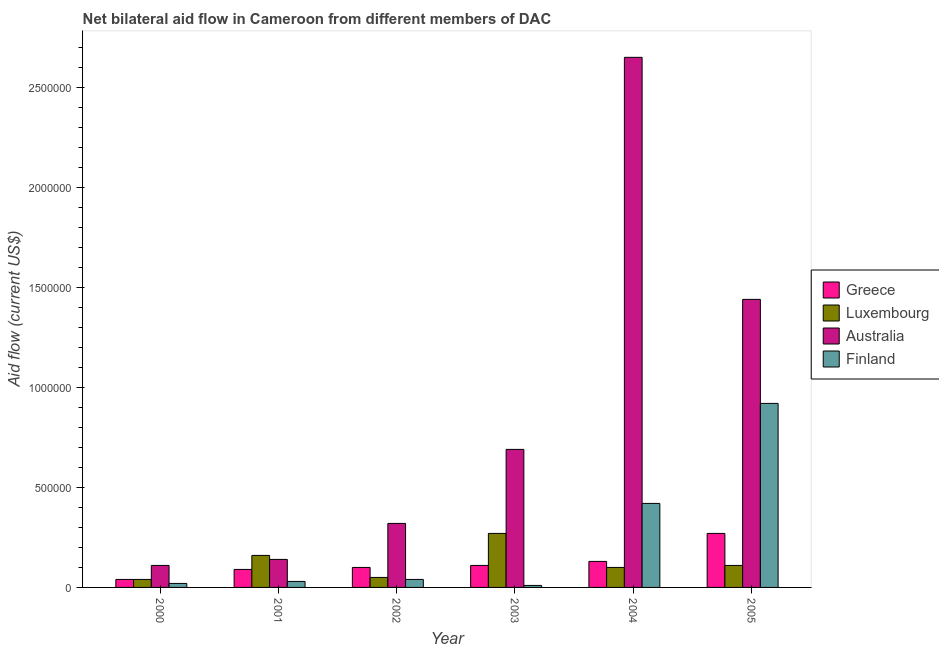How many groups of bars are there?
Your answer should be very brief. 6. How many bars are there on the 2nd tick from the left?
Provide a short and direct response. 4. How many bars are there on the 6th tick from the right?
Offer a terse response. 4. What is the label of the 1st group of bars from the left?
Keep it short and to the point. 2000. What is the amount of aid given by finland in 2001?
Keep it short and to the point. 3.00e+04. Across all years, what is the maximum amount of aid given by finland?
Your response must be concise. 9.20e+05. Across all years, what is the minimum amount of aid given by australia?
Make the answer very short. 1.10e+05. In which year was the amount of aid given by luxembourg maximum?
Provide a short and direct response. 2003. In which year was the amount of aid given by luxembourg minimum?
Your answer should be very brief. 2000. What is the total amount of aid given by finland in the graph?
Provide a succinct answer. 1.44e+06. What is the difference between the amount of aid given by greece in 2001 and that in 2005?
Give a very brief answer. -1.80e+05. What is the difference between the amount of aid given by luxembourg in 2003 and the amount of aid given by finland in 2001?
Your answer should be very brief. 1.10e+05. In the year 2001, what is the difference between the amount of aid given by luxembourg and amount of aid given by greece?
Your answer should be very brief. 0. What is the ratio of the amount of aid given by greece in 2002 to that in 2004?
Your answer should be very brief. 0.77. Is the amount of aid given by greece in 2001 less than that in 2002?
Ensure brevity in your answer.  Yes. Is the difference between the amount of aid given by australia in 2003 and 2004 greater than the difference between the amount of aid given by finland in 2003 and 2004?
Your response must be concise. No. What is the difference between the highest and the lowest amount of aid given by finland?
Keep it short and to the point. 9.10e+05. Is it the case that in every year, the sum of the amount of aid given by greece and amount of aid given by luxembourg is greater than the sum of amount of aid given by australia and amount of aid given by finland?
Make the answer very short. No. Is it the case that in every year, the sum of the amount of aid given by greece and amount of aid given by luxembourg is greater than the amount of aid given by australia?
Make the answer very short. No. How many bars are there?
Offer a terse response. 24. Are all the bars in the graph horizontal?
Provide a succinct answer. No. How many years are there in the graph?
Your answer should be very brief. 6. How are the legend labels stacked?
Give a very brief answer. Vertical. What is the title of the graph?
Your response must be concise. Net bilateral aid flow in Cameroon from different members of DAC. What is the label or title of the X-axis?
Give a very brief answer. Year. What is the Aid flow (current US$) in Luxembourg in 2000?
Provide a short and direct response. 4.00e+04. What is the Aid flow (current US$) in Australia in 2000?
Make the answer very short. 1.10e+05. What is the Aid flow (current US$) of Greece in 2001?
Ensure brevity in your answer.  9.00e+04. What is the Aid flow (current US$) in Luxembourg in 2001?
Offer a terse response. 1.60e+05. What is the Aid flow (current US$) in Australia in 2001?
Keep it short and to the point. 1.40e+05. What is the Aid flow (current US$) of Finland in 2001?
Your answer should be very brief. 3.00e+04. What is the Aid flow (current US$) of Greece in 2002?
Provide a short and direct response. 1.00e+05. What is the Aid flow (current US$) of Finland in 2002?
Make the answer very short. 4.00e+04. What is the Aid flow (current US$) of Luxembourg in 2003?
Offer a terse response. 2.70e+05. What is the Aid flow (current US$) of Australia in 2003?
Your answer should be very brief. 6.90e+05. What is the Aid flow (current US$) in Finland in 2003?
Your answer should be very brief. 10000. What is the Aid flow (current US$) in Australia in 2004?
Keep it short and to the point. 2.65e+06. What is the Aid flow (current US$) in Australia in 2005?
Give a very brief answer. 1.44e+06. What is the Aid flow (current US$) of Finland in 2005?
Offer a very short reply. 9.20e+05. Across all years, what is the maximum Aid flow (current US$) of Greece?
Your answer should be very brief. 2.70e+05. Across all years, what is the maximum Aid flow (current US$) of Australia?
Offer a terse response. 2.65e+06. Across all years, what is the maximum Aid flow (current US$) in Finland?
Give a very brief answer. 9.20e+05. Across all years, what is the minimum Aid flow (current US$) in Greece?
Your answer should be compact. 4.00e+04. Across all years, what is the minimum Aid flow (current US$) of Luxembourg?
Your answer should be compact. 4.00e+04. Across all years, what is the minimum Aid flow (current US$) of Finland?
Your answer should be very brief. 10000. What is the total Aid flow (current US$) in Greece in the graph?
Provide a succinct answer. 7.40e+05. What is the total Aid flow (current US$) of Luxembourg in the graph?
Your answer should be compact. 7.30e+05. What is the total Aid flow (current US$) of Australia in the graph?
Keep it short and to the point. 5.35e+06. What is the total Aid flow (current US$) in Finland in the graph?
Give a very brief answer. 1.44e+06. What is the difference between the Aid flow (current US$) of Luxembourg in 2000 and that in 2001?
Provide a short and direct response. -1.20e+05. What is the difference between the Aid flow (current US$) in Australia in 2000 and that in 2001?
Offer a very short reply. -3.00e+04. What is the difference between the Aid flow (current US$) in Finland in 2000 and that in 2001?
Provide a short and direct response. -10000. What is the difference between the Aid flow (current US$) of Greece in 2000 and that in 2002?
Your answer should be compact. -6.00e+04. What is the difference between the Aid flow (current US$) in Luxembourg in 2000 and that in 2002?
Your answer should be very brief. -10000. What is the difference between the Aid flow (current US$) in Finland in 2000 and that in 2002?
Your answer should be very brief. -2.00e+04. What is the difference between the Aid flow (current US$) in Australia in 2000 and that in 2003?
Make the answer very short. -5.80e+05. What is the difference between the Aid flow (current US$) of Finland in 2000 and that in 2003?
Provide a short and direct response. 10000. What is the difference between the Aid flow (current US$) in Greece in 2000 and that in 2004?
Your response must be concise. -9.00e+04. What is the difference between the Aid flow (current US$) in Australia in 2000 and that in 2004?
Offer a very short reply. -2.54e+06. What is the difference between the Aid flow (current US$) in Finland in 2000 and that in 2004?
Ensure brevity in your answer.  -4.00e+05. What is the difference between the Aid flow (current US$) of Greece in 2000 and that in 2005?
Your answer should be compact. -2.30e+05. What is the difference between the Aid flow (current US$) in Australia in 2000 and that in 2005?
Ensure brevity in your answer.  -1.33e+06. What is the difference between the Aid flow (current US$) of Finland in 2000 and that in 2005?
Give a very brief answer. -9.00e+05. What is the difference between the Aid flow (current US$) of Australia in 2001 and that in 2002?
Provide a short and direct response. -1.80e+05. What is the difference between the Aid flow (current US$) of Australia in 2001 and that in 2003?
Your answer should be compact. -5.50e+05. What is the difference between the Aid flow (current US$) in Luxembourg in 2001 and that in 2004?
Your answer should be very brief. 6.00e+04. What is the difference between the Aid flow (current US$) in Australia in 2001 and that in 2004?
Provide a short and direct response. -2.51e+06. What is the difference between the Aid flow (current US$) of Finland in 2001 and that in 2004?
Offer a terse response. -3.90e+05. What is the difference between the Aid flow (current US$) of Australia in 2001 and that in 2005?
Your answer should be very brief. -1.30e+06. What is the difference between the Aid flow (current US$) in Finland in 2001 and that in 2005?
Keep it short and to the point. -8.90e+05. What is the difference between the Aid flow (current US$) of Luxembourg in 2002 and that in 2003?
Your answer should be very brief. -2.20e+05. What is the difference between the Aid flow (current US$) of Australia in 2002 and that in 2003?
Give a very brief answer. -3.70e+05. What is the difference between the Aid flow (current US$) in Greece in 2002 and that in 2004?
Make the answer very short. -3.00e+04. What is the difference between the Aid flow (current US$) of Australia in 2002 and that in 2004?
Provide a short and direct response. -2.33e+06. What is the difference between the Aid flow (current US$) in Finland in 2002 and that in 2004?
Make the answer very short. -3.80e+05. What is the difference between the Aid flow (current US$) in Luxembourg in 2002 and that in 2005?
Your response must be concise. -6.00e+04. What is the difference between the Aid flow (current US$) in Australia in 2002 and that in 2005?
Provide a short and direct response. -1.12e+06. What is the difference between the Aid flow (current US$) of Finland in 2002 and that in 2005?
Your answer should be very brief. -8.80e+05. What is the difference between the Aid flow (current US$) in Greece in 2003 and that in 2004?
Your answer should be compact. -2.00e+04. What is the difference between the Aid flow (current US$) of Luxembourg in 2003 and that in 2004?
Offer a very short reply. 1.70e+05. What is the difference between the Aid flow (current US$) in Australia in 2003 and that in 2004?
Keep it short and to the point. -1.96e+06. What is the difference between the Aid flow (current US$) in Finland in 2003 and that in 2004?
Ensure brevity in your answer.  -4.10e+05. What is the difference between the Aid flow (current US$) in Greece in 2003 and that in 2005?
Your answer should be very brief. -1.60e+05. What is the difference between the Aid flow (current US$) of Australia in 2003 and that in 2005?
Your answer should be compact. -7.50e+05. What is the difference between the Aid flow (current US$) of Finland in 2003 and that in 2005?
Keep it short and to the point. -9.10e+05. What is the difference between the Aid flow (current US$) of Australia in 2004 and that in 2005?
Give a very brief answer. 1.21e+06. What is the difference between the Aid flow (current US$) in Finland in 2004 and that in 2005?
Provide a short and direct response. -5.00e+05. What is the difference between the Aid flow (current US$) of Greece in 2000 and the Aid flow (current US$) of Luxembourg in 2001?
Your answer should be very brief. -1.20e+05. What is the difference between the Aid flow (current US$) in Greece in 2000 and the Aid flow (current US$) in Finland in 2001?
Offer a very short reply. 10000. What is the difference between the Aid flow (current US$) in Luxembourg in 2000 and the Aid flow (current US$) in Finland in 2001?
Ensure brevity in your answer.  10000. What is the difference between the Aid flow (current US$) of Greece in 2000 and the Aid flow (current US$) of Australia in 2002?
Offer a terse response. -2.80e+05. What is the difference between the Aid flow (current US$) of Luxembourg in 2000 and the Aid flow (current US$) of Australia in 2002?
Your answer should be compact. -2.80e+05. What is the difference between the Aid flow (current US$) of Luxembourg in 2000 and the Aid flow (current US$) of Finland in 2002?
Provide a succinct answer. 0. What is the difference between the Aid flow (current US$) of Greece in 2000 and the Aid flow (current US$) of Luxembourg in 2003?
Offer a terse response. -2.30e+05. What is the difference between the Aid flow (current US$) in Greece in 2000 and the Aid flow (current US$) in Australia in 2003?
Offer a terse response. -6.50e+05. What is the difference between the Aid flow (current US$) of Greece in 2000 and the Aid flow (current US$) of Finland in 2003?
Ensure brevity in your answer.  3.00e+04. What is the difference between the Aid flow (current US$) in Luxembourg in 2000 and the Aid flow (current US$) in Australia in 2003?
Your response must be concise. -6.50e+05. What is the difference between the Aid flow (current US$) in Luxembourg in 2000 and the Aid flow (current US$) in Finland in 2003?
Give a very brief answer. 3.00e+04. What is the difference between the Aid flow (current US$) of Greece in 2000 and the Aid flow (current US$) of Luxembourg in 2004?
Offer a very short reply. -6.00e+04. What is the difference between the Aid flow (current US$) in Greece in 2000 and the Aid flow (current US$) in Australia in 2004?
Give a very brief answer. -2.61e+06. What is the difference between the Aid flow (current US$) in Greece in 2000 and the Aid flow (current US$) in Finland in 2004?
Offer a very short reply. -3.80e+05. What is the difference between the Aid flow (current US$) in Luxembourg in 2000 and the Aid flow (current US$) in Australia in 2004?
Make the answer very short. -2.61e+06. What is the difference between the Aid flow (current US$) of Luxembourg in 2000 and the Aid flow (current US$) of Finland in 2004?
Provide a short and direct response. -3.80e+05. What is the difference between the Aid flow (current US$) of Australia in 2000 and the Aid flow (current US$) of Finland in 2004?
Offer a very short reply. -3.10e+05. What is the difference between the Aid flow (current US$) in Greece in 2000 and the Aid flow (current US$) in Australia in 2005?
Give a very brief answer. -1.40e+06. What is the difference between the Aid flow (current US$) in Greece in 2000 and the Aid flow (current US$) in Finland in 2005?
Give a very brief answer. -8.80e+05. What is the difference between the Aid flow (current US$) in Luxembourg in 2000 and the Aid flow (current US$) in Australia in 2005?
Offer a very short reply. -1.40e+06. What is the difference between the Aid flow (current US$) in Luxembourg in 2000 and the Aid flow (current US$) in Finland in 2005?
Provide a short and direct response. -8.80e+05. What is the difference between the Aid flow (current US$) of Australia in 2000 and the Aid flow (current US$) of Finland in 2005?
Your answer should be compact. -8.10e+05. What is the difference between the Aid flow (current US$) of Greece in 2001 and the Aid flow (current US$) of Australia in 2002?
Your answer should be very brief. -2.30e+05. What is the difference between the Aid flow (current US$) of Greece in 2001 and the Aid flow (current US$) of Finland in 2002?
Offer a very short reply. 5.00e+04. What is the difference between the Aid flow (current US$) in Luxembourg in 2001 and the Aid flow (current US$) in Australia in 2002?
Offer a very short reply. -1.60e+05. What is the difference between the Aid flow (current US$) of Luxembourg in 2001 and the Aid flow (current US$) of Finland in 2002?
Offer a very short reply. 1.20e+05. What is the difference between the Aid flow (current US$) of Greece in 2001 and the Aid flow (current US$) of Luxembourg in 2003?
Your answer should be compact. -1.80e+05. What is the difference between the Aid flow (current US$) in Greece in 2001 and the Aid flow (current US$) in Australia in 2003?
Provide a succinct answer. -6.00e+05. What is the difference between the Aid flow (current US$) of Luxembourg in 2001 and the Aid flow (current US$) of Australia in 2003?
Make the answer very short. -5.30e+05. What is the difference between the Aid flow (current US$) in Luxembourg in 2001 and the Aid flow (current US$) in Finland in 2003?
Your answer should be compact. 1.50e+05. What is the difference between the Aid flow (current US$) in Australia in 2001 and the Aid flow (current US$) in Finland in 2003?
Your answer should be compact. 1.30e+05. What is the difference between the Aid flow (current US$) in Greece in 2001 and the Aid flow (current US$) in Luxembourg in 2004?
Provide a succinct answer. -10000. What is the difference between the Aid flow (current US$) of Greece in 2001 and the Aid flow (current US$) of Australia in 2004?
Offer a terse response. -2.56e+06. What is the difference between the Aid flow (current US$) of Greece in 2001 and the Aid flow (current US$) of Finland in 2004?
Give a very brief answer. -3.30e+05. What is the difference between the Aid flow (current US$) in Luxembourg in 2001 and the Aid flow (current US$) in Australia in 2004?
Give a very brief answer. -2.49e+06. What is the difference between the Aid flow (current US$) in Luxembourg in 2001 and the Aid flow (current US$) in Finland in 2004?
Make the answer very short. -2.60e+05. What is the difference between the Aid flow (current US$) of Australia in 2001 and the Aid flow (current US$) of Finland in 2004?
Offer a very short reply. -2.80e+05. What is the difference between the Aid flow (current US$) of Greece in 2001 and the Aid flow (current US$) of Luxembourg in 2005?
Offer a very short reply. -2.00e+04. What is the difference between the Aid flow (current US$) in Greece in 2001 and the Aid flow (current US$) in Australia in 2005?
Offer a terse response. -1.35e+06. What is the difference between the Aid flow (current US$) of Greece in 2001 and the Aid flow (current US$) of Finland in 2005?
Your answer should be very brief. -8.30e+05. What is the difference between the Aid flow (current US$) of Luxembourg in 2001 and the Aid flow (current US$) of Australia in 2005?
Provide a succinct answer. -1.28e+06. What is the difference between the Aid flow (current US$) in Luxembourg in 2001 and the Aid flow (current US$) in Finland in 2005?
Offer a very short reply. -7.60e+05. What is the difference between the Aid flow (current US$) in Australia in 2001 and the Aid flow (current US$) in Finland in 2005?
Your answer should be very brief. -7.80e+05. What is the difference between the Aid flow (current US$) of Greece in 2002 and the Aid flow (current US$) of Luxembourg in 2003?
Offer a terse response. -1.70e+05. What is the difference between the Aid flow (current US$) in Greece in 2002 and the Aid flow (current US$) in Australia in 2003?
Offer a very short reply. -5.90e+05. What is the difference between the Aid flow (current US$) of Luxembourg in 2002 and the Aid flow (current US$) of Australia in 2003?
Give a very brief answer. -6.40e+05. What is the difference between the Aid flow (current US$) of Luxembourg in 2002 and the Aid flow (current US$) of Finland in 2003?
Give a very brief answer. 4.00e+04. What is the difference between the Aid flow (current US$) in Australia in 2002 and the Aid flow (current US$) in Finland in 2003?
Your response must be concise. 3.10e+05. What is the difference between the Aid flow (current US$) in Greece in 2002 and the Aid flow (current US$) in Australia in 2004?
Make the answer very short. -2.55e+06. What is the difference between the Aid flow (current US$) in Greece in 2002 and the Aid flow (current US$) in Finland in 2004?
Make the answer very short. -3.20e+05. What is the difference between the Aid flow (current US$) of Luxembourg in 2002 and the Aid flow (current US$) of Australia in 2004?
Ensure brevity in your answer.  -2.60e+06. What is the difference between the Aid flow (current US$) in Luxembourg in 2002 and the Aid flow (current US$) in Finland in 2004?
Provide a short and direct response. -3.70e+05. What is the difference between the Aid flow (current US$) in Greece in 2002 and the Aid flow (current US$) in Australia in 2005?
Your response must be concise. -1.34e+06. What is the difference between the Aid flow (current US$) in Greece in 2002 and the Aid flow (current US$) in Finland in 2005?
Make the answer very short. -8.20e+05. What is the difference between the Aid flow (current US$) in Luxembourg in 2002 and the Aid flow (current US$) in Australia in 2005?
Your response must be concise. -1.39e+06. What is the difference between the Aid flow (current US$) in Luxembourg in 2002 and the Aid flow (current US$) in Finland in 2005?
Provide a short and direct response. -8.70e+05. What is the difference between the Aid flow (current US$) in Australia in 2002 and the Aid flow (current US$) in Finland in 2005?
Your response must be concise. -6.00e+05. What is the difference between the Aid flow (current US$) of Greece in 2003 and the Aid flow (current US$) of Australia in 2004?
Your answer should be compact. -2.54e+06. What is the difference between the Aid flow (current US$) in Greece in 2003 and the Aid flow (current US$) in Finland in 2004?
Give a very brief answer. -3.10e+05. What is the difference between the Aid flow (current US$) in Luxembourg in 2003 and the Aid flow (current US$) in Australia in 2004?
Keep it short and to the point. -2.38e+06. What is the difference between the Aid flow (current US$) of Greece in 2003 and the Aid flow (current US$) of Luxembourg in 2005?
Offer a terse response. 0. What is the difference between the Aid flow (current US$) in Greece in 2003 and the Aid flow (current US$) in Australia in 2005?
Offer a terse response. -1.33e+06. What is the difference between the Aid flow (current US$) in Greece in 2003 and the Aid flow (current US$) in Finland in 2005?
Offer a terse response. -8.10e+05. What is the difference between the Aid flow (current US$) of Luxembourg in 2003 and the Aid flow (current US$) of Australia in 2005?
Provide a succinct answer. -1.17e+06. What is the difference between the Aid flow (current US$) of Luxembourg in 2003 and the Aid flow (current US$) of Finland in 2005?
Offer a very short reply. -6.50e+05. What is the difference between the Aid flow (current US$) in Australia in 2003 and the Aid flow (current US$) in Finland in 2005?
Offer a very short reply. -2.30e+05. What is the difference between the Aid flow (current US$) of Greece in 2004 and the Aid flow (current US$) of Luxembourg in 2005?
Ensure brevity in your answer.  2.00e+04. What is the difference between the Aid flow (current US$) in Greece in 2004 and the Aid flow (current US$) in Australia in 2005?
Your response must be concise. -1.31e+06. What is the difference between the Aid flow (current US$) of Greece in 2004 and the Aid flow (current US$) of Finland in 2005?
Ensure brevity in your answer.  -7.90e+05. What is the difference between the Aid flow (current US$) of Luxembourg in 2004 and the Aid flow (current US$) of Australia in 2005?
Offer a very short reply. -1.34e+06. What is the difference between the Aid flow (current US$) in Luxembourg in 2004 and the Aid flow (current US$) in Finland in 2005?
Your response must be concise. -8.20e+05. What is the difference between the Aid flow (current US$) in Australia in 2004 and the Aid flow (current US$) in Finland in 2005?
Ensure brevity in your answer.  1.73e+06. What is the average Aid flow (current US$) in Greece per year?
Your answer should be very brief. 1.23e+05. What is the average Aid flow (current US$) in Luxembourg per year?
Your response must be concise. 1.22e+05. What is the average Aid flow (current US$) of Australia per year?
Your answer should be very brief. 8.92e+05. What is the average Aid flow (current US$) of Finland per year?
Ensure brevity in your answer.  2.40e+05. In the year 2000, what is the difference between the Aid flow (current US$) of Greece and Aid flow (current US$) of Luxembourg?
Ensure brevity in your answer.  0. In the year 2000, what is the difference between the Aid flow (current US$) of Greece and Aid flow (current US$) of Finland?
Provide a short and direct response. 2.00e+04. In the year 2001, what is the difference between the Aid flow (current US$) of Greece and Aid flow (current US$) of Luxembourg?
Ensure brevity in your answer.  -7.00e+04. In the year 2001, what is the difference between the Aid flow (current US$) in Australia and Aid flow (current US$) in Finland?
Ensure brevity in your answer.  1.10e+05. In the year 2002, what is the difference between the Aid flow (current US$) in Greece and Aid flow (current US$) in Australia?
Give a very brief answer. -2.20e+05. In the year 2002, what is the difference between the Aid flow (current US$) in Luxembourg and Aid flow (current US$) in Australia?
Offer a very short reply. -2.70e+05. In the year 2002, what is the difference between the Aid flow (current US$) in Luxembourg and Aid flow (current US$) in Finland?
Provide a short and direct response. 10000. In the year 2003, what is the difference between the Aid flow (current US$) of Greece and Aid flow (current US$) of Australia?
Provide a short and direct response. -5.80e+05. In the year 2003, what is the difference between the Aid flow (current US$) in Luxembourg and Aid flow (current US$) in Australia?
Offer a terse response. -4.20e+05. In the year 2003, what is the difference between the Aid flow (current US$) in Luxembourg and Aid flow (current US$) in Finland?
Provide a short and direct response. 2.60e+05. In the year 2003, what is the difference between the Aid flow (current US$) in Australia and Aid flow (current US$) in Finland?
Your answer should be compact. 6.80e+05. In the year 2004, what is the difference between the Aid flow (current US$) in Greece and Aid flow (current US$) in Luxembourg?
Your answer should be very brief. 3.00e+04. In the year 2004, what is the difference between the Aid flow (current US$) of Greece and Aid flow (current US$) of Australia?
Your answer should be very brief. -2.52e+06. In the year 2004, what is the difference between the Aid flow (current US$) of Greece and Aid flow (current US$) of Finland?
Ensure brevity in your answer.  -2.90e+05. In the year 2004, what is the difference between the Aid flow (current US$) of Luxembourg and Aid flow (current US$) of Australia?
Offer a terse response. -2.55e+06. In the year 2004, what is the difference between the Aid flow (current US$) in Luxembourg and Aid flow (current US$) in Finland?
Your answer should be very brief. -3.20e+05. In the year 2004, what is the difference between the Aid flow (current US$) of Australia and Aid flow (current US$) of Finland?
Give a very brief answer. 2.23e+06. In the year 2005, what is the difference between the Aid flow (current US$) in Greece and Aid flow (current US$) in Australia?
Offer a very short reply. -1.17e+06. In the year 2005, what is the difference between the Aid flow (current US$) of Greece and Aid flow (current US$) of Finland?
Your response must be concise. -6.50e+05. In the year 2005, what is the difference between the Aid flow (current US$) in Luxembourg and Aid flow (current US$) in Australia?
Your answer should be compact. -1.33e+06. In the year 2005, what is the difference between the Aid flow (current US$) of Luxembourg and Aid flow (current US$) of Finland?
Your response must be concise. -8.10e+05. In the year 2005, what is the difference between the Aid flow (current US$) of Australia and Aid flow (current US$) of Finland?
Make the answer very short. 5.20e+05. What is the ratio of the Aid flow (current US$) of Greece in 2000 to that in 2001?
Provide a short and direct response. 0.44. What is the ratio of the Aid flow (current US$) of Australia in 2000 to that in 2001?
Ensure brevity in your answer.  0.79. What is the ratio of the Aid flow (current US$) in Luxembourg in 2000 to that in 2002?
Make the answer very short. 0.8. What is the ratio of the Aid flow (current US$) of Australia in 2000 to that in 2002?
Keep it short and to the point. 0.34. What is the ratio of the Aid flow (current US$) of Finland in 2000 to that in 2002?
Give a very brief answer. 0.5. What is the ratio of the Aid flow (current US$) of Greece in 2000 to that in 2003?
Your answer should be compact. 0.36. What is the ratio of the Aid flow (current US$) in Luxembourg in 2000 to that in 2003?
Provide a short and direct response. 0.15. What is the ratio of the Aid flow (current US$) of Australia in 2000 to that in 2003?
Provide a succinct answer. 0.16. What is the ratio of the Aid flow (current US$) in Finland in 2000 to that in 2003?
Ensure brevity in your answer.  2. What is the ratio of the Aid flow (current US$) in Greece in 2000 to that in 2004?
Keep it short and to the point. 0.31. What is the ratio of the Aid flow (current US$) of Australia in 2000 to that in 2004?
Make the answer very short. 0.04. What is the ratio of the Aid flow (current US$) of Finland in 2000 to that in 2004?
Your answer should be very brief. 0.05. What is the ratio of the Aid flow (current US$) of Greece in 2000 to that in 2005?
Provide a succinct answer. 0.15. What is the ratio of the Aid flow (current US$) of Luxembourg in 2000 to that in 2005?
Offer a very short reply. 0.36. What is the ratio of the Aid flow (current US$) in Australia in 2000 to that in 2005?
Provide a succinct answer. 0.08. What is the ratio of the Aid flow (current US$) of Finland in 2000 to that in 2005?
Keep it short and to the point. 0.02. What is the ratio of the Aid flow (current US$) of Luxembourg in 2001 to that in 2002?
Make the answer very short. 3.2. What is the ratio of the Aid flow (current US$) of Australia in 2001 to that in 2002?
Offer a terse response. 0.44. What is the ratio of the Aid flow (current US$) in Greece in 2001 to that in 2003?
Your response must be concise. 0.82. What is the ratio of the Aid flow (current US$) of Luxembourg in 2001 to that in 2003?
Offer a very short reply. 0.59. What is the ratio of the Aid flow (current US$) of Australia in 2001 to that in 2003?
Make the answer very short. 0.2. What is the ratio of the Aid flow (current US$) in Greece in 2001 to that in 2004?
Your answer should be compact. 0.69. What is the ratio of the Aid flow (current US$) of Australia in 2001 to that in 2004?
Offer a very short reply. 0.05. What is the ratio of the Aid flow (current US$) in Finland in 2001 to that in 2004?
Offer a very short reply. 0.07. What is the ratio of the Aid flow (current US$) in Luxembourg in 2001 to that in 2005?
Offer a very short reply. 1.45. What is the ratio of the Aid flow (current US$) in Australia in 2001 to that in 2005?
Offer a very short reply. 0.1. What is the ratio of the Aid flow (current US$) in Finland in 2001 to that in 2005?
Your answer should be compact. 0.03. What is the ratio of the Aid flow (current US$) of Luxembourg in 2002 to that in 2003?
Your response must be concise. 0.19. What is the ratio of the Aid flow (current US$) in Australia in 2002 to that in 2003?
Offer a terse response. 0.46. What is the ratio of the Aid flow (current US$) of Finland in 2002 to that in 2003?
Offer a very short reply. 4. What is the ratio of the Aid flow (current US$) in Greece in 2002 to that in 2004?
Your answer should be very brief. 0.77. What is the ratio of the Aid flow (current US$) of Luxembourg in 2002 to that in 2004?
Offer a very short reply. 0.5. What is the ratio of the Aid flow (current US$) in Australia in 2002 to that in 2004?
Provide a succinct answer. 0.12. What is the ratio of the Aid flow (current US$) of Finland in 2002 to that in 2004?
Keep it short and to the point. 0.1. What is the ratio of the Aid flow (current US$) of Greece in 2002 to that in 2005?
Offer a terse response. 0.37. What is the ratio of the Aid flow (current US$) of Luxembourg in 2002 to that in 2005?
Keep it short and to the point. 0.45. What is the ratio of the Aid flow (current US$) of Australia in 2002 to that in 2005?
Your response must be concise. 0.22. What is the ratio of the Aid flow (current US$) in Finland in 2002 to that in 2005?
Offer a terse response. 0.04. What is the ratio of the Aid flow (current US$) of Greece in 2003 to that in 2004?
Offer a terse response. 0.85. What is the ratio of the Aid flow (current US$) of Australia in 2003 to that in 2004?
Give a very brief answer. 0.26. What is the ratio of the Aid flow (current US$) in Finland in 2003 to that in 2004?
Make the answer very short. 0.02. What is the ratio of the Aid flow (current US$) of Greece in 2003 to that in 2005?
Offer a very short reply. 0.41. What is the ratio of the Aid flow (current US$) of Luxembourg in 2003 to that in 2005?
Give a very brief answer. 2.45. What is the ratio of the Aid flow (current US$) in Australia in 2003 to that in 2005?
Your response must be concise. 0.48. What is the ratio of the Aid flow (current US$) in Finland in 2003 to that in 2005?
Offer a very short reply. 0.01. What is the ratio of the Aid flow (current US$) of Greece in 2004 to that in 2005?
Provide a succinct answer. 0.48. What is the ratio of the Aid flow (current US$) in Australia in 2004 to that in 2005?
Your response must be concise. 1.84. What is the ratio of the Aid flow (current US$) in Finland in 2004 to that in 2005?
Provide a short and direct response. 0.46. What is the difference between the highest and the second highest Aid flow (current US$) in Greece?
Provide a short and direct response. 1.40e+05. What is the difference between the highest and the second highest Aid flow (current US$) of Australia?
Give a very brief answer. 1.21e+06. What is the difference between the highest and the lowest Aid flow (current US$) in Luxembourg?
Your answer should be compact. 2.30e+05. What is the difference between the highest and the lowest Aid flow (current US$) of Australia?
Ensure brevity in your answer.  2.54e+06. What is the difference between the highest and the lowest Aid flow (current US$) of Finland?
Provide a succinct answer. 9.10e+05. 